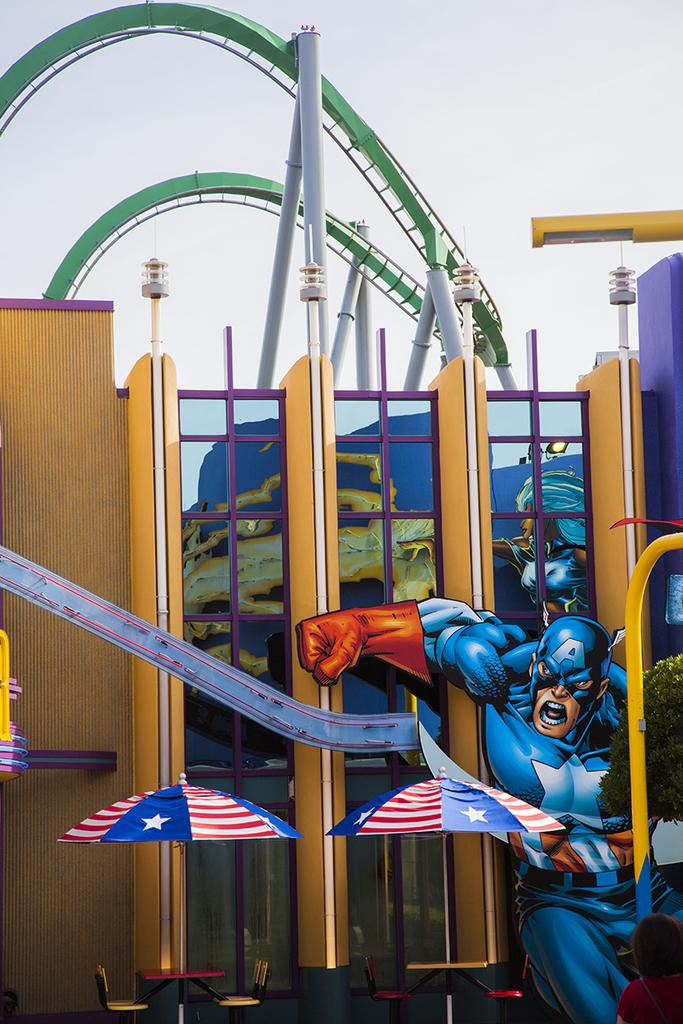What type of furniture is present in the image? There are tables and chairs in the image. What type of shelter is provided in the image? There are umbrellas in the image. What type of structure is visible in the image? There is a building in the image. Are there any people present in the image? Yes, there are people in the image. What type of illumination is present in the image? There is light in the image. What type of support structures are present in the image? There are poles in the image. What other objects can be seen in the image? There are other objects in the image, but their specific details are not mentioned. What can be seen in the background of the image? The sky is visible in the background of the image. How many shoes are visible on the dock in the image? There is no dock or shoes present in the image. What type of leg is visible on the people in the image? The image does not show the legs of the people, so it cannot be determined what type of leg is visible. 